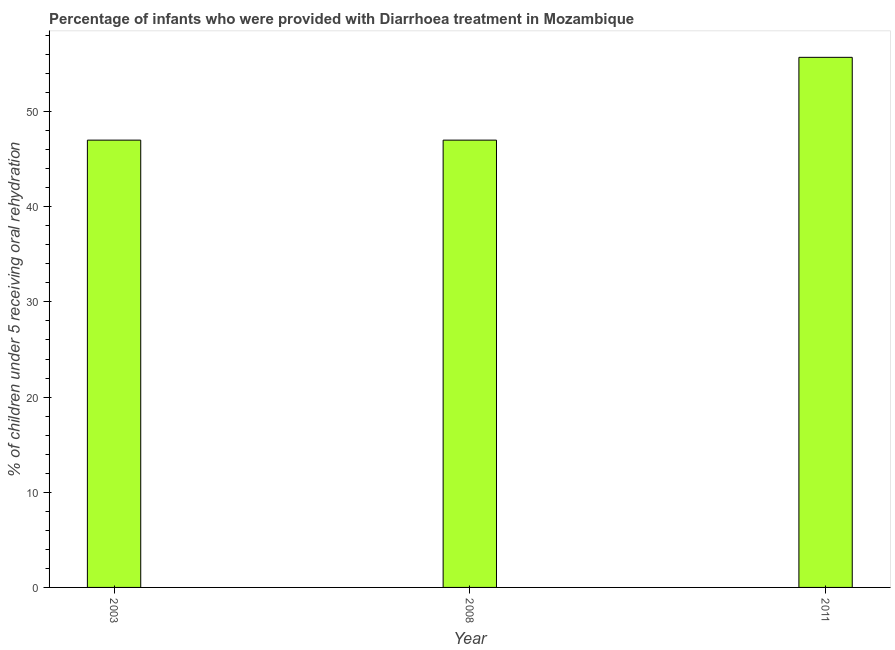Does the graph contain grids?
Give a very brief answer. No. What is the title of the graph?
Make the answer very short. Percentage of infants who were provided with Diarrhoea treatment in Mozambique. What is the label or title of the X-axis?
Make the answer very short. Year. What is the label or title of the Y-axis?
Offer a terse response. % of children under 5 receiving oral rehydration. What is the percentage of children who were provided with treatment diarrhoea in 2008?
Your answer should be compact. 47. Across all years, what is the maximum percentage of children who were provided with treatment diarrhoea?
Ensure brevity in your answer.  55.7. Across all years, what is the minimum percentage of children who were provided with treatment diarrhoea?
Offer a terse response. 47. In which year was the percentage of children who were provided with treatment diarrhoea maximum?
Your answer should be very brief. 2011. In which year was the percentage of children who were provided with treatment diarrhoea minimum?
Provide a succinct answer. 2003. What is the sum of the percentage of children who were provided with treatment diarrhoea?
Make the answer very short. 149.7. What is the average percentage of children who were provided with treatment diarrhoea per year?
Give a very brief answer. 49.9. What is the median percentage of children who were provided with treatment diarrhoea?
Your answer should be very brief. 47. What is the ratio of the percentage of children who were provided with treatment diarrhoea in 2008 to that in 2011?
Give a very brief answer. 0.84. What is the difference between the highest and the second highest percentage of children who were provided with treatment diarrhoea?
Give a very brief answer. 8.7. Is the sum of the percentage of children who were provided with treatment diarrhoea in 2003 and 2008 greater than the maximum percentage of children who were provided with treatment diarrhoea across all years?
Your answer should be very brief. Yes. How many bars are there?
Keep it short and to the point. 3. Are all the bars in the graph horizontal?
Your answer should be compact. No. Are the values on the major ticks of Y-axis written in scientific E-notation?
Your response must be concise. No. What is the % of children under 5 receiving oral rehydration of 2003?
Keep it short and to the point. 47. What is the % of children under 5 receiving oral rehydration of 2008?
Give a very brief answer. 47. What is the % of children under 5 receiving oral rehydration of 2011?
Your answer should be very brief. 55.7. What is the difference between the % of children under 5 receiving oral rehydration in 2003 and 2011?
Make the answer very short. -8.7. What is the ratio of the % of children under 5 receiving oral rehydration in 2003 to that in 2011?
Your answer should be very brief. 0.84. What is the ratio of the % of children under 5 receiving oral rehydration in 2008 to that in 2011?
Offer a terse response. 0.84. 